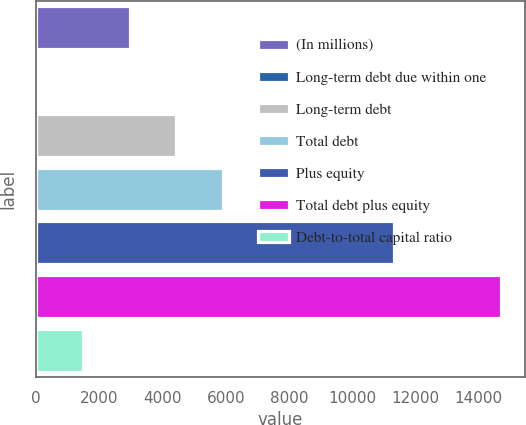Convert chart to OTSL. <chart><loc_0><loc_0><loc_500><loc_500><bar_chart><fcel>(In millions)<fcel>Long-term debt due within one<fcel>Long-term debt<fcel>Total debt<fcel>Plus equity<fcel>Total debt plus equity<fcel>Debt-to-total capital ratio<nl><fcel>2964<fcel>23<fcel>4434.5<fcel>5905<fcel>11332<fcel>14728<fcel>1493.5<nl></chart> 